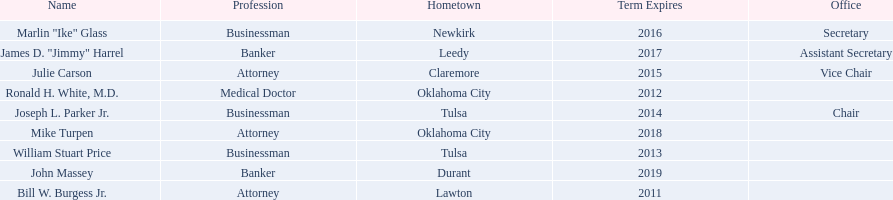Who are the businessmen? Bill W. Burgess Jr., Ronald H. White, M.D., William Stuart Price, Joseph L. Parker Jr., Julie Carson, Marlin "Ike" Glass, James D. "Jimmy" Harrel, Mike Turpen, John Massey. Which were born in tulsa? William Stuart Price, Joseph L. Parker Jr. Of these, which one was other than william stuart price? Joseph L. Parker Jr. 